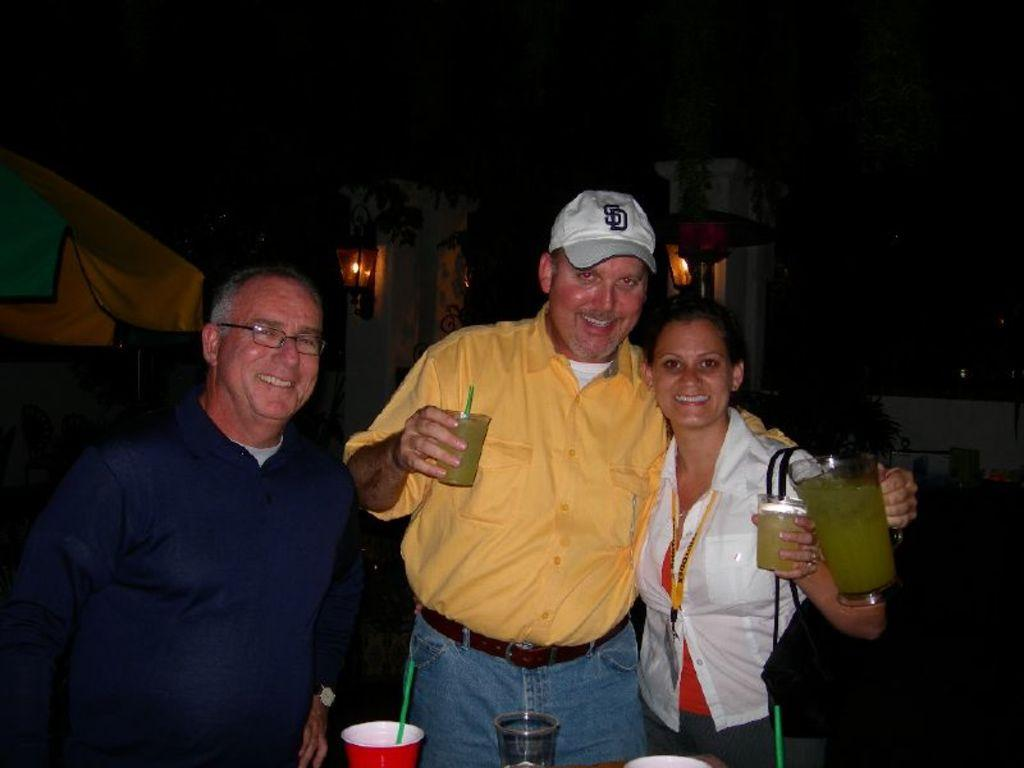<image>
Summarize the visual content of the image. A man with a yellow shirt is wearing a SD ball cap. 